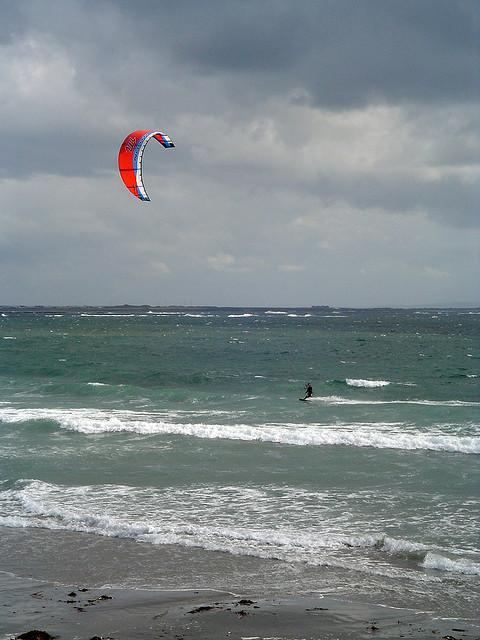What is the boarder about to hit? wave 